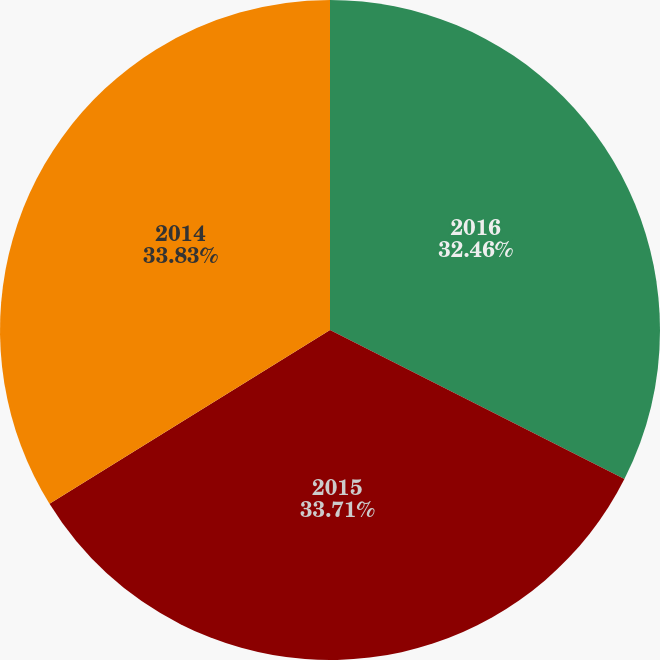Convert chart to OTSL. <chart><loc_0><loc_0><loc_500><loc_500><pie_chart><fcel>2016<fcel>2015<fcel>2014<nl><fcel>32.46%<fcel>33.71%<fcel>33.83%<nl></chart> 